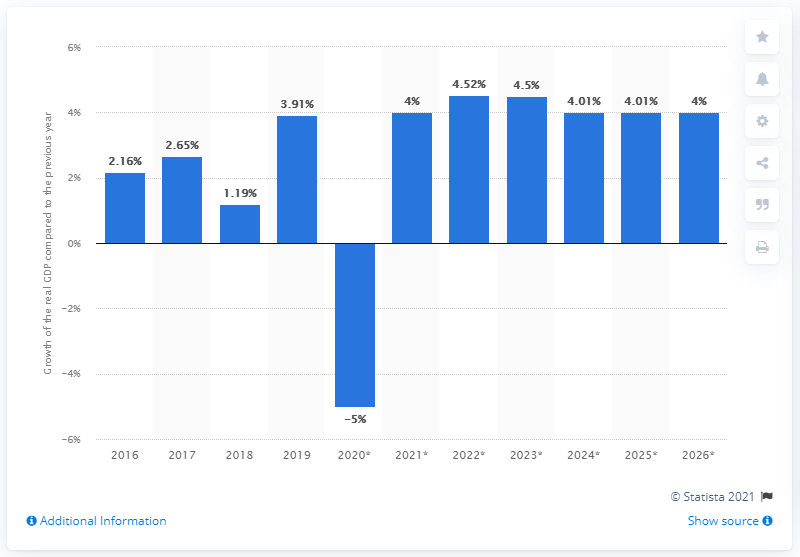Mention a couple of crucial points in this snapshot. In 2016, Afghanistan's gross domestic product grew by 3.91 percent. Afghanistan's gross domestic product (GDP) grew by 3.91% in 2019. 